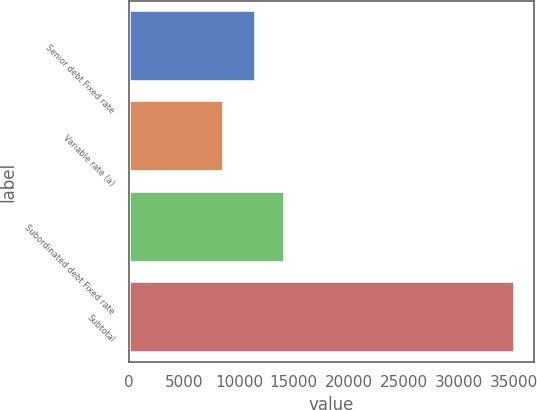Convert chart. <chart><loc_0><loc_0><loc_500><loc_500><bar_chart><fcel>Senior debt Fixed rate<fcel>Variable rate (a)<fcel>Subordinated debt Fixed rate<fcel>Subtotal<nl><fcel>11516<fcel>8657<fcel>14159.8<fcel>35095<nl></chart> 